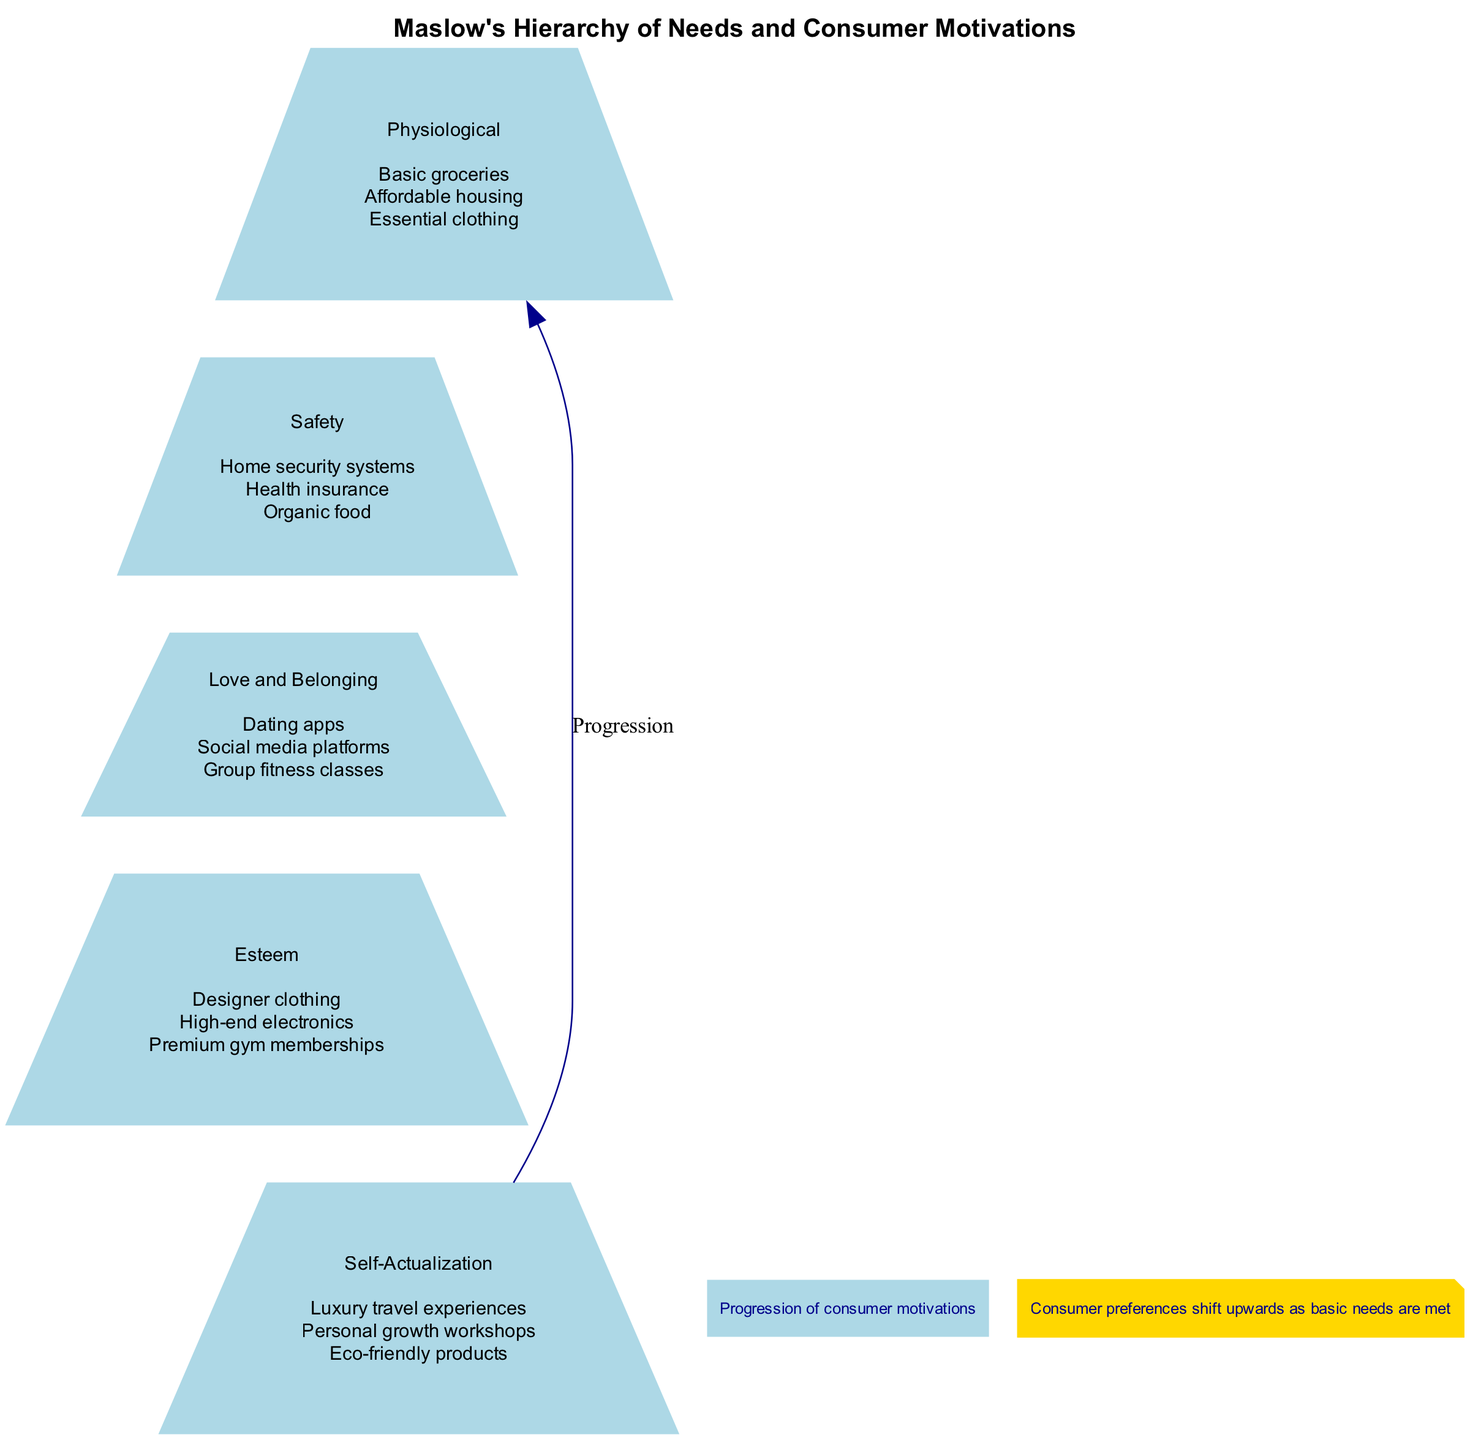What is the top level of Maslow's Hierarchy of Needs? The top level of the pyramid is labeled "Self-Actualization," which is the highest need in Maslow's hierarchy related to personal growth and fulfillment.
Answer: Self-Actualization How many consumer examples are listed under the Esteem level? The Esteem level includes three consumer examples: "Designer clothing," "High-end electronics," and "Premium gym memberships." Counting these gives a total of three examples.
Answer: 3 Which level is immediately above the Safety level? The level directly above the Safety level, based on the pyramid's structure, is the Love and Belonging level. This is determined by following the progression from Safety to the next higher level.
Answer: Love and Belonging What do consumer motivations progress from and to according to the diagram? The diagram illustrates that consumer motivations progress from basic physiological needs at the bottom of the pyramid to self-actualization at the top, emphasizing the shift in consumer priorities as their basic needs are satisfied.
Answer: Physiological to Self-Actualization Which consumer example is associated with Love and Belonging? Under the Love and Belonging level, the consumer example "Dating apps" is listed as part of this category. Identifying this level reveals examples related to social connections and relationships.
Answer: Dating apps What is the main note provided in the diagram? The note beneath the diagram states, "Consumer preferences shift upwards as basic needs are met," summarizing the key theme of the pyramid related to how consumers choose products as they achieve higher levels of needs.
Answer: Consumer preferences shift upwards as basic needs are met How many levels are displayed in the pyramid? The diagram clearly showcases five distinct levels of Maslow's Hierarchy: Self-Actualization, Esteem, Love and Belonging, Safety, and Physiological. Counting these levels reveals that there are five in total.
Answer: 5 What is the color of the nodes in the pyramid diagram? The nodes representing each level in the pyramid are filled with light blue color, which is indicated in the attributes defined for the graph's nodes.
Answer: Light blue What type of products are associated with the Self-Actualization level? The consumer examples listed under Self-Actualization include "Luxury travel experiences," "Personal growth workshops," and "Eco-friendly products," focusing on products that reflect individual fulfillment and growth.
Answer: Luxury travel experiences, Personal growth workshops, Eco-friendly products 